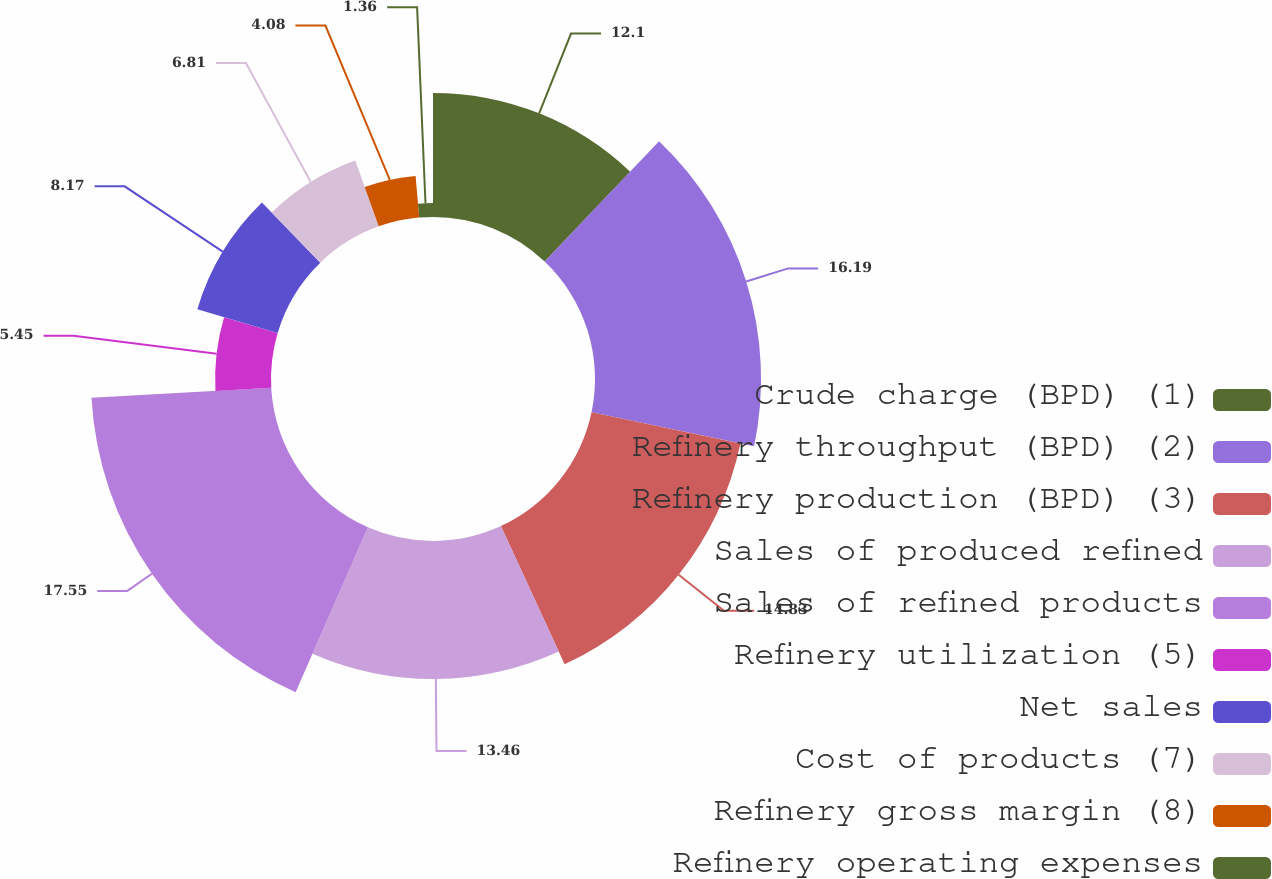Convert chart to OTSL. <chart><loc_0><loc_0><loc_500><loc_500><pie_chart><fcel>Crude charge (BPD) (1)<fcel>Refinery throughput (BPD) (2)<fcel>Refinery production (BPD) (3)<fcel>Sales of produced refined<fcel>Sales of refined products<fcel>Refinery utilization (5)<fcel>Net sales<fcel>Cost of products (7)<fcel>Refinery gross margin (8)<fcel>Refinery operating expenses<nl><fcel>12.1%<fcel>16.19%<fcel>14.83%<fcel>13.46%<fcel>17.55%<fcel>5.45%<fcel>8.17%<fcel>6.81%<fcel>4.08%<fcel>1.36%<nl></chart> 